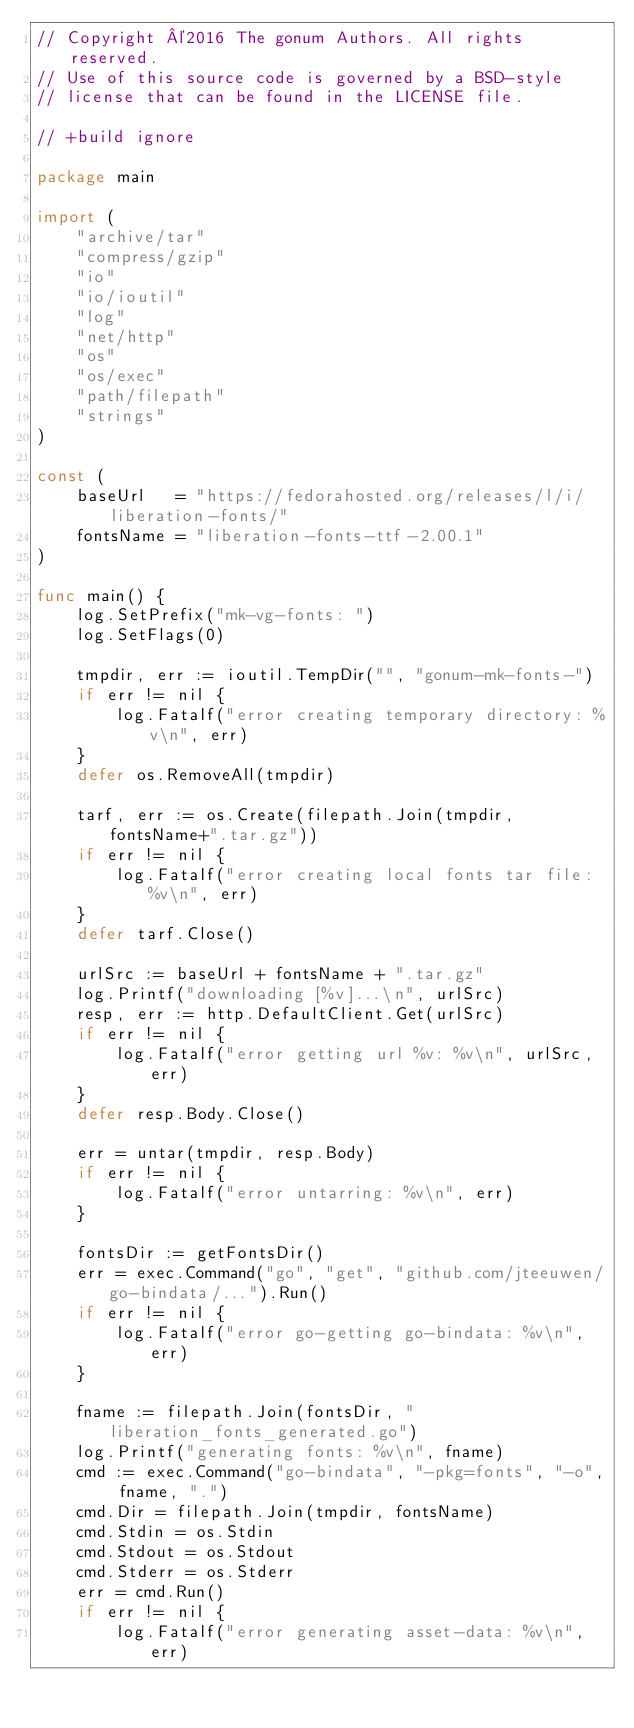<code> <loc_0><loc_0><loc_500><loc_500><_Go_>// Copyright ©2016 The gonum Authors. All rights reserved.
// Use of this source code is governed by a BSD-style
// license that can be found in the LICENSE file.

// +build ignore

package main

import (
	"archive/tar"
	"compress/gzip"
	"io"
	"io/ioutil"
	"log"
	"net/http"
	"os"
	"os/exec"
	"path/filepath"
	"strings"
)

const (
	baseUrl   = "https://fedorahosted.org/releases/l/i/liberation-fonts/"
	fontsName = "liberation-fonts-ttf-2.00.1"
)

func main() {
	log.SetPrefix("mk-vg-fonts: ")
	log.SetFlags(0)

	tmpdir, err := ioutil.TempDir("", "gonum-mk-fonts-")
	if err != nil {
		log.Fatalf("error creating temporary directory: %v\n", err)
	}
	defer os.RemoveAll(tmpdir)

	tarf, err := os.Create(filepath.Join(tmpdir, fontsName+".tar.gz"))
	if err != nil {
		log.Fatalf("error creating local fonts tar file: %v\n", err)
	}
	defer tarf.Close()

	urlSrc := baseUrl + fontsName + ".tar.gz"
	log.Printf("downloading [%v]...\n", urlSrc)
	resp, err := http.DefaultClient.Get(urlSrc)
	if err != nil {
		log.Fatalf("error getting url %v: %v\n", urlSrc, err)
	}
	defer resp.Body.Close()

	err = untar(tmpdir, resp.Body)
	if err != nil {
		log.Fatalf("error untarring: %v\n", err)
	}

	fontsDir := getFontsDir()
	err = exec.Command("go", "get", "github.com/jteeuwen/go-bindata/...").Run()
	if err != nil {
		log.Fatalf("error go-getting go-bindata: %v\n", err)
	}

	fname := filepath.Join(fontsDir, "liberation_fonts_generated.go")
	log.Printf("generating fonts: %v\n", fname)
	cmd := exec.Command("go-bindata", "-pkg=fonts", "-o", fname, ".")
	cmd.Dir = filepath.Join(tmpdir, fontsName)
	cmd.Stdin = os.Stdin
	cmd.Stdout = os.Stdout
	cmd.Stderr = os.Stderr
	err = cmd.Run()
	if err != nil {
		log.Fatalf("error generating asset-data: %v\n", err)</code> 